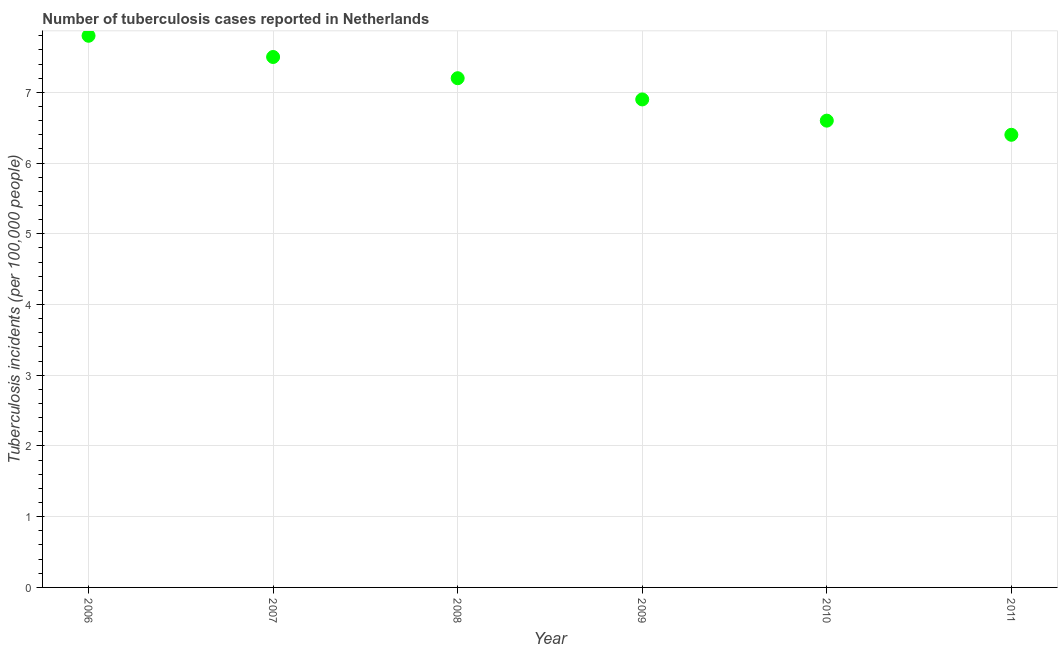What is the number of tuberculosis incidents in 2008?
Offer a terse response. 7.2. Across all years, what is the minimum number of tuberculosis incidents?
Keep it short and to the point. 6.4. What is the sum of the number of tuberculosis incidents?
Offer a terse response. 42.4. What is the difference between the number of tuberculosis incidents in 2008 and 2009?
Provide a succinct answer. 0.3. What is the average number of tuberculosis incidents per year?
Offer a terse response. 7.07. What is the median number of tuberculosis incidents?
Your answer should be very brief. 7.05. Is the number of tuberculosis incidents in 2006 less than that in 2008?
Provide a succinct answer. No. Is the difference between the number of tuberculosis incidents in 2007 and 2010 greater than the difference between any two years?
Provide a succinct answer. No. What is the difference between the highest and the second highest number of tuberculosis incidents?
Offer a terse response. 0.3. Is the sum of the number of tuberculosis incidents in 2009 and 2010 greater than the maximum number of tuberculosis incidents across all years?
Provide a short and direct response. Yes. What is the difference between the highest and the lowest number of tuberculosis incidents?
Give a very brief answer. 1.4. Does the number of tuberculosis incidents monotonically increase over the years?
Ensure brevity in your answer.  No. How many dotlines are there?
Ensure brevity in your answer.  1. What is the difference between two consecutive major ticks on the Y-axis?
Provide a short and direct response. 1. Are the values on the major ticks of Y-axis written in scientific E-notation?
Your response must be concise. No. What is the title of the graph?
Make the answer very short. Number of tuberculosis cases reported in Netherlands. What is the label or title of the X-axis?
Your answer should be very brief. Year. What is the label or title of the Y-axis?
Provide a short and direct response. Tuberculosis incidents (per 100,0 people). What is the Tuberculosis incidents (per 100,000 people) in 2006?
Your response must be concise. 7.8. What is the Tuberculosis incidents (per 100,000 people) in 2007?
Offer a very short reply. 7.5. What is the difference between the Tuberculosis incidents (per 100,000 people) in 2006 and 2007?
Offer a very short reply. 0.3. What is the difference between the Tuberculosis incidents (per 100,000 people) in 2006 and 2008?
Keep it short and to the point. 0.6. What is the difference between the Tuberculosis incidents (per 100,000 people) in 2006 and 2010?
Keep it short and to the point. 1.2. What is the difference between the Tuberculosis incidents (per 100,000 people) in 2007 and 2009?
Offer a very short reply. 0.6. What is the difference between the Tuberculosis incidents (per 100,000 people) in 2007 and 2011?
Provide a short and direct response. 1.1. What is the difference between the Tuberculosis incidents (per 100,000 people) in 2008 and 2009?
Give a very brief answer. 0.3. What is the difference between the Tuberculosis incidents (per 100,000 people) in 2008 and 2010?
Your answer should be very brief. 0.6. What is the difference between the Tuberculosis incidents (per 100,000 people) in 2008 and 2011?
Your answer should be compact. 0.8. What is the difference between the Tuberculosis incidents (per 100,000 people) in 2009 and 2011?
Your answer should be compact. 0.5. What is the ratio of the Tuberculosis incidents (per 100,000 people) in 2006 to that in 2007?
Provide a short and direct response. 1.04. What is the ratio of the Tuberculosis incidents (per 100,000 people) in 2006 to that in 2008?
Give a very brief answer. 1.08. What is the ratio of the Tuberculosis incidents (per 100,000 people) in 2006 to that in 2009?
Ensure brevity in your answer.  1.13. What is the ratio of the Tuberculosis incidents (per 100,000 people) in 2006 to that in 2010?
Your answer should be compact. 1.18. What is the ratio of the Tuberculosis incidents (per 100,000 people) in 2006 to that in 2011?
Give a very brief answer. 1.22. What is the ratio of the Tuberculosis incidents (per 100,000 people) in 2007 to that in 2008?
Give a very brief answer. 1.04. What is the ratio of the Tuberculosis incidents (per 100,000 people) in 2007 to that in 2009?
Provide a short and direct response. 1.09. What is the ratio of the Tuberculosis incidents (per 100,000 people) in 2007 to that in 2010?
Make the answer very short. 1.14. What is the ratio of the Tuberculosis incidents (per 100,000 people) in 2007 to that in 2011?
Make the answer very short. 1.17. What is the ratio of the Tuberculosis incidents (per 100,000 people) in 2008 to that in 2009?
Make the answer very short. 1.04. What is the ratio of the Tuberculosis incidents (per 100,000 people) in 2008 to that in 2010?
Your answer should be compact. 1.09. What is the ratio of the Tuberculosis incidents (per 100,000 people) in 2008 to that in 2011?
Your response must be concise. 1.12. What is the ratio of the Tuberculosis incidents (per 100,000 people) in 2009 to that in 2010?
Your answer should be compact. 1.04. What is the ratio of the Tuberculosis incidents (per 100,000 people) in 2009 to that in 2011?
Ensure brevity in your answer.  1.08. What is the ratio of the Tuberculosis incidents (per 100,000 people) in 2010 to that in 2011?
Ensure brevity in your answer.  1.03. 